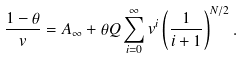Convert formula to latex. <formula><loc_0><loc_0><loc_500><loc_500>\frac { 1 - \theta } { v } = A _ { \infty } + \theta Q \sum _ { i = 0 } ^ { \infty } v ^ { i } \left ( \frac { 1 } { i + 1 } \right ) ^ { N / 2 } .</formula> 